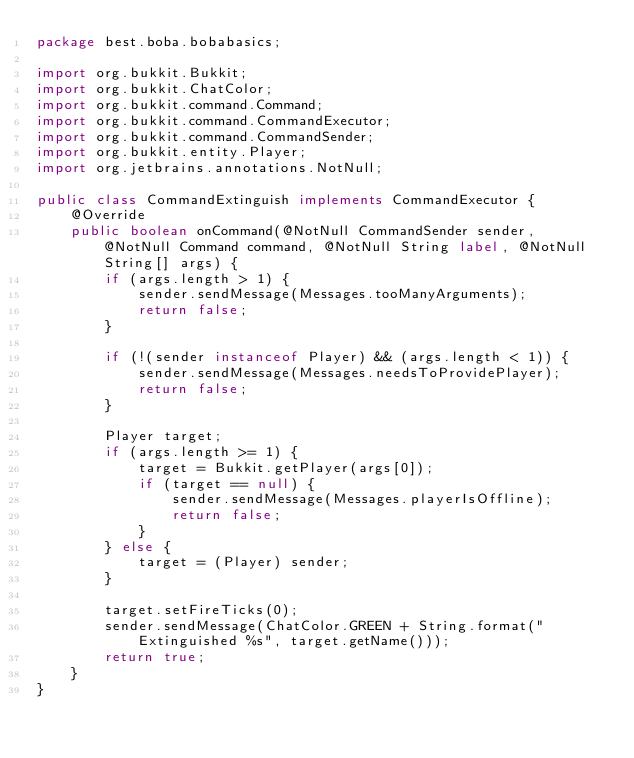Convert code to text. <code><loc_0><loc_0><loc_500><loc_500><_Java_>package best.boba.bobabasics;

import org.bukkit.Bukkit;
import org.bukkit.ChatColor;
import org.bukkit.command.Command;
import org.bukkit.command.CommandExecutor;
import org.bukkit.command.CommandSender;
import org.bukkit.entity.Player;
import org.jetbrains.annotations.NotNull;

public class CommandExtinguish implements CommandExecutor {
    @Override
    public boolean onCommand(@NotNull CommandSender sender, @NotNull Command command, @NotNull String label, @NotNull String[] args) {
        if (args.length > 1) {
            sender.sendMessage(Messages.tooManyArguments);
            return false;
        }

        if (!(sender instanceof Player) && (args.length < 1)) {
            sender.sendMessage(Messages.needsToProvidePlayer);
            return false;
        }

        Player target;
        if (args.length >= 1) {
            target = Bukkit.getPlayer(args[0]);
            if (target == null) {
                sender.sendMessage(Messages.playerIsOffline);
                return false;
            }
        } else {
            target = (Player) sender;
        }

        target.setFireTicks(0);
        sender.sendMessage(ChatColor.GREEN + String.format("Extinguished %s", target.getName()));
        return true;
    }
}
</code> 